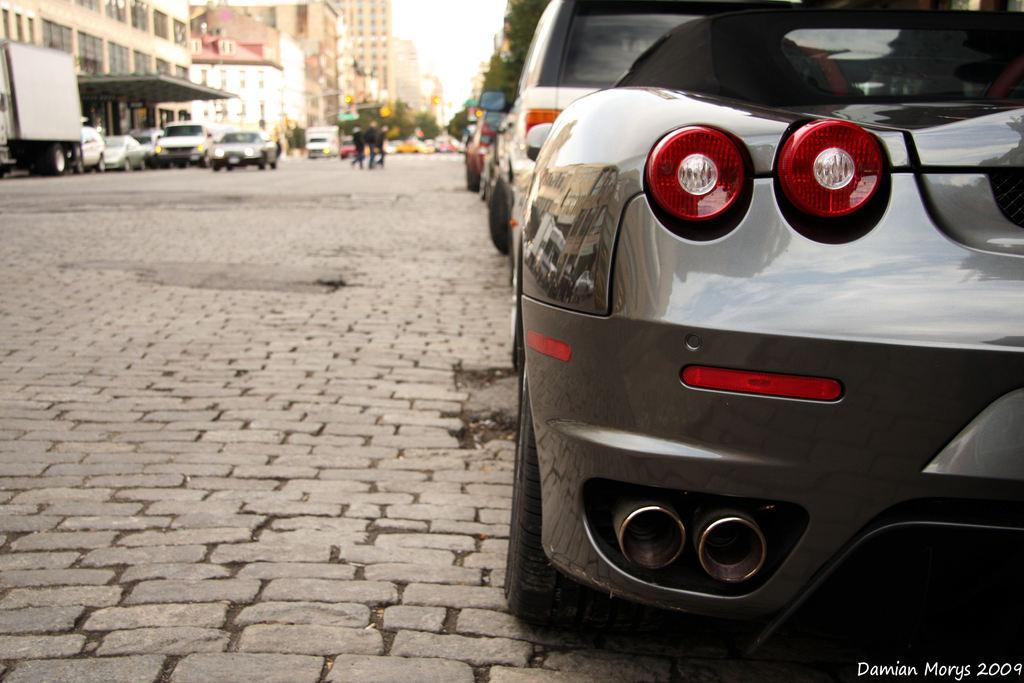What is the main feature of the image? There is a road in the image. What is happening on the road? There are vehicles on the road, and there are people on the road as well. Can you describe the vehicles on the road? The vehicles have different colors. What can be seen in the background of the image? There are buildings, trees, and the sky visible in the background of the image. What type of grip can be seen on the flesh of the people in the image? There is no mention of grip or flesh in the image; it features a road with vehicles and people. 